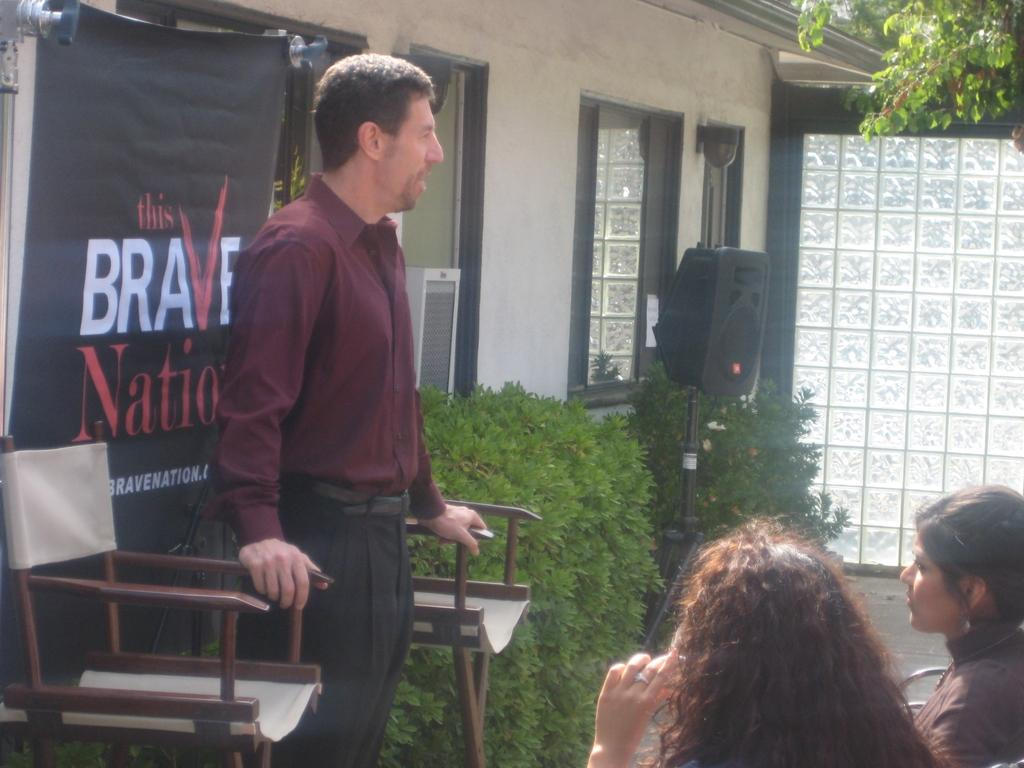How many people are in the image? There are two women and a man in the image. What objects are present for sitting in the image? There are chairs in the image. What type of vegetation is visible in the image? There are plants and a tree in the image. What device is present for amplifying sound in the image? There is a speaker in the image. What type of structure can be seen in the background of the image? There is a house in the background of the image. What type of dress is the man wearing in the image? The man in the image is not wearing a dress; he is wearing regular clothing. What type of collar can be seen on the plants in the image? There are no collars present on the plants in the image; they are simply plants. 